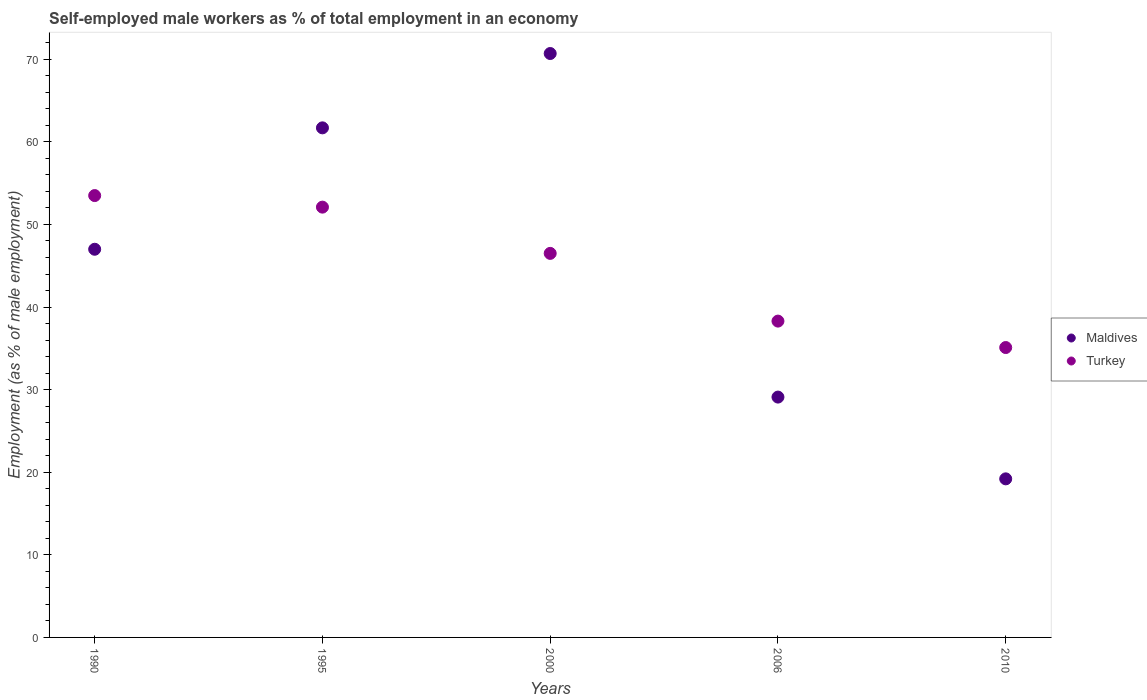How many different coloured dotlines are there?
Your response must be concise. 2. What is the percentage of self-employed male workers in Turkey in 2006?
Keep it short and to the point. 38.3. Across all years, what is the maximum percentage of self-employed male workers in Maldives?
Keep it short and to the point. 70.7. Across all years, what is the minimum percentage of self-employed male workers in Turkey?
Provide a succinct answer. 35.1. In which year was the percentage of self-employed male workers in Maldives minimum?
Ensure brevity in your answer.  2010. What is the total percentage of self-employed male workers in Turkey in the graph?
Give a very brief answer. 225.5. What is the difference between the percentage of self-employed male workers in Turkey in 2006 and that in 2010?
Offer a terse response. 3.2. What is the difference between the percentage of self-employed male workers in Maldives in 1995 and the percentage of self-employed male workers in Turkey in 2010?
Provide a succinct answer. 26.6. What is the average percentage of self-employed male workers in Maldives per year?
Your response must be concise. 45.54. In the year 1990, what is the difference between the percentage of self-employed male workers in Turkey and percentage of self-employed male workers in Maldives?
Provide a short and direct response. 6.5. In how many years, is the percentage of self-employed male workers in Turkey greater than 34 %?
Ensure brevity in your answer.  5. What is the ratio of the percentage of self-employed male workers in Turkey in 1990 to that in 2010?
Your answer should be compact. 1.52. Is the difference between the percentage of self-employed male workers in Turkey in 1990 and 2006 greater than the difference between the percentage of self-employed male workers in Maldives in 1990 and 2006?
Offer a terse response. No. What is the difference between the highest and the second highest percentage of self-employed male workers in Turkey?
Make the answer very short. 1.4. What is the difference between the highest and the lowest percentage of self-employed male workers in Turkey?
Offer a terse response. 18.4. In how many years, is the percentage of self-employed male workers in Maldives greater than the average percentage of self-employed male workers in Maldives taken over all years?
Make the answer very short. 3. Does the percentage of self-employed male workers in Maldives monotonically increase over the years?
Keep it short and to the point. No. Is the percentage of self-employed male workers in Turkey strictly less than the percentage of self-employed male workers in Maldives over the years?
Give a very brief answer. No. How many years are there in the graph?
Give a very brief answer. 5. What is the title of the graph?
Keep it short and to the point. Self-employed male workers as % of total employment in an economy. Does "Singapore" appear as one of the legend labels in the graph?
Offer a very short reply. No. What is the label or title of the X-axis?
Make the answer very short. Years. What is the label or title of the Y-axis?
Offer a terse response. Employment (as % of male employment). What is the Employment (as % of male employment) in Turkey in 1990?
Give a very brief answer. 53.5. What is the Employment (as % of male employment) in Maldives in 1995?
Your answer should be compact. 61.7. What is the Employment (as % of male employment) in Turkey in 1995?
Provide a succinct answer. 52.1. What is the Employment (as % of male employment) in Maldives in 2000?
Provide a succinct answer. 70.7. What is the Employment (as % of male employment) in Turkey in 2000?
Keep it short and to the point. 46.5. What is the Employment (as % of male employment) of Maldives in 2006?
Your response must be concise. 29.1. What is the Employment (as % of male employment) of Turkey in 2006?
Provide a short and direct response. 38.3. What is the Employment (as % of male employment) of Maldives in 2010?
Provide a short and direct response. 19.2. What is the Employment (as % of male employment) in Turkey in 2010?
Your response must be concise. 35.1. Across all years, what is the maximum Employment (as % of male employment) of Maldives?
Offer a very short reply. 70.7. Across all years, what is the maximum Employment (as % of male employment) in Turkey?
Make the answer very short. 53.5. Across all years, what is the minimum Employment (as % of male employment) of Maldives?
Make the answer very short. 19.2. Across all years, what is the minimum Employment (as % of male employment) in Turkey?
Your answer should be very brief. 35.1. What is the total Employment (as % of male employment) of Maldives in the graph?
Provide a short and direct response. 227.7. What is the total Employment (as % of male employment) of Turkey in the graph?
Your response must be concise. 225.5. What is the difference between the Employment (as % of male employment) of Maldives in 1990 and that in 1995?
Offer a very short reply. -14.7. What is the difference between the Employment (as % of male employment) of Maldives in 1990 and that in 2000?
Provide a succinct answer. -23.7. What is the difference between the Employment (as % of male employment) in Maldives in 1990 and that in 2006?
Your response must be concise. 17.9. What is the difference between the Employment (as % of male employment) of Turkey in 1990 and that in 2006?
Ensure brevity in your answer.  15.2. What is the difference between the Employment (as % of male employment) in Maldives in 1990 and that in 2010?
Keep it short and to the point. 27.8. What is the difference between the Employment (as % of male employment) in Turkey in 1990 and that in 2010?
Provide a short and direct response. 18.4. What is the difference between the Employment (as % of male employment) in Maldives in 1995 and that in 2000?
Give a very brief answer. -9. What is the difference between the Employment (as % of male employment) of Maldives in 1995 and that in 2006?
Keep it short and to the point. 32.6. What is the difference between the Employment (as % of male employment) in Turkey in 1995 and that in 2006?
Offer a very short reply. 13.8. What is the difference between the Employment (as % of male employment) of Maldives in 1995 and that in 2010?
Your response must be concise. 42.5. What is the difference between the Employment (as % of male employment) of Turkey in 1995 and that in 2010?
Your answer should be compact. 17. What is the difference between the Employment (as % of male employment) in Maldives in 2000 and that in 2006?
Give a very brief answer. 41.6. What is the difference between the Employment (as % of male employment) in Turkey in 2000 and that in 2006?
Give a very brief answer. 8.2. What is the difference between the Employment (as % of male employment) of Maldives in 2000 and that in 2010?
Your answer should be compact. 51.5. What is the difference between the Employment (as % of male employment) in Maldives in 2006 and that in 2010?
Your answer should be compact. 9.9. What is the difference between the Employment (as % of male employment) in Turkey in 2006 and that in 2010?
Your answer should be very brief. 3.2. What is the difference between the Employment (as % of male employment) of Maldives in 1990 and the Employment (as % of male employment) of Turkey in 2000?
Provide a short and direct response. 0.5. What is the difference between the Employment (as % of male employment) in Maldives in 1990 and the Employment (as % of male employment) in Turkey in 2010?
Keep it short and to the point. 11.9. What is the difference between the Employment (as % of male employment) of Maldives in 1995 and the Employment (as % of male employment) of Turkey in 2006?
Give a very brief answer. 23.4. What is the difference between the Employment (as % of male employment) of Maldives in 1995 and the Employment (as % of male employment) of Turkey in 2010?
Provide a succinct answer. 26.6. What is the difference between the Employment (as % of male employment) in Maldives in 2000 and the Employment (as % of male employment) in Turkey in 2006?
Your answer should be compact. 32.4. What is the difference between the Employment (as % of male employment) of Maldives in 2000 and the Employment (as % of male employment) of Turkey in 2010?
Offer a very short reply. 35.6. What is the difference between the Employment (as % of male employment) in Maldives in 2006 and the Employment (as % of male employment) in Turkey in 2010?
Keep it short and to the point. -6. What is the average Employment (as % of male employment) of Maldives per year?
Provide a short and direct response. 45.54. What is the average Employment (as % of male employment) of Turkey per year?
Provide a succinct answer. 45.1. In the year 1995, what is the difference between the Employment (as % of male employment) in Maldives and Employment (as % of male employment) in Turkey?
Ensure brevity in your answer.  9.6. In the year 2000, what is the difference between the Employment (as % of male employment) in Maldives and Employment (as % of male employment) in Turkey?
Offer a very short reply. 24.2. In the year 2010, what is the difference between the Employment (as % of male employment) of Maldives and Employment (as % of male employment) of Turkey?
Make the answer very short. -15.9. What is the ratio of the Employment (as % of male employment) in Maldives in 1990 to that in 1995?
Keep it short and to the point. 0.76. What is the ratio of the Employment (as % of male employment) of Turkey in 1990 to that in 1995?
Offer a very short reply. 1.03. What is the ratio of the Employment (as % of male employment) in Maldives in 1990 to that in 2000?
Ensure brevity in your answer.  0.66. What is the ratio of the Employment (as % of male employment) in Turkey in 1990 to that in 2000?
Your answer should be very brief. 1.15. What is the ratio of the Employment (as % of male employment) of Maldives in 1990 to that in 2006?
Provide a short and direct response. 1.62. What is the ratio of the Employment (as % of male employment) of Turkey in 1990 to that in 2006?
Provide a succinct answer. 1.4. What is the ratio of the Employment (as % of male employment) of Maldives in 1990 to that in 2010?
Give a very brief answer. 2.45. What is the ratio of the Employment (as % of male employment) in Turkey in 1990 to that in 2010?
Your answer should be very brief. 1.52. What is the ratio of the Employment (as % of male employment) in Maldives in 1995 to that in 2000?
Keep it short and to the point. 0.87. What is the ratio of the Employment (as % of male employment) in Turkey in 1995 to that in 2000?
Make the answer very short. 1.12. What is the ratio of the Employment (as % of male employment) in Maldives in 1995 to that in 2006?
Provide a short and direct response. 2.12. What is the ratio of the Employment (as % of male employment) in Turkey in 1995 to that in 2006?
Offer a terse response. 1.36. What is the ratio of the Employment (as % of male employment) of Maldives in 1995 to that in 2010?
Your response must be concise. 3.21. What is the ratio of the Employment (as % of male employment) in Turkey in 1995 to that in 2010?
Your answer should be compact. 1.48. What is the ratio of the Employment (as % of male employment) of Maldives in 2000 to that in 2006?
Offer a very short reply. 2.43. What is the ratio of the Employment (as % of male employment) of Turkey in 2000 to that in 2006?
Your response must be concise. 1.21. What is the ratio of the Employment (as % of male employment) in Maldives in 2000 to that in 2010?
Your answer should be compact. 3.68. What is the ratio of the Employment (as % of male employment) of Turkey in 2000 to that in 2010?
Provide a succinct answer. 1.32. What is the ratio of the Employment (as % of male employment) of Maldives in 2006 to that in 2010?
Your answer should be compact. 1.52. What is the ratio of the Employment (as % of male employment) in Turkey in 2006 to that in 2010?
Keep it short and to the point. 1.09. What is the difference between the highest and the second highest Employment (as % of male employment) in Maldives?
Provide a short and direct response. 9. What is the difference between the highest and the lowest Employment (as % of male employment) in Maldives?
Offer a very short reply. 51.5. 